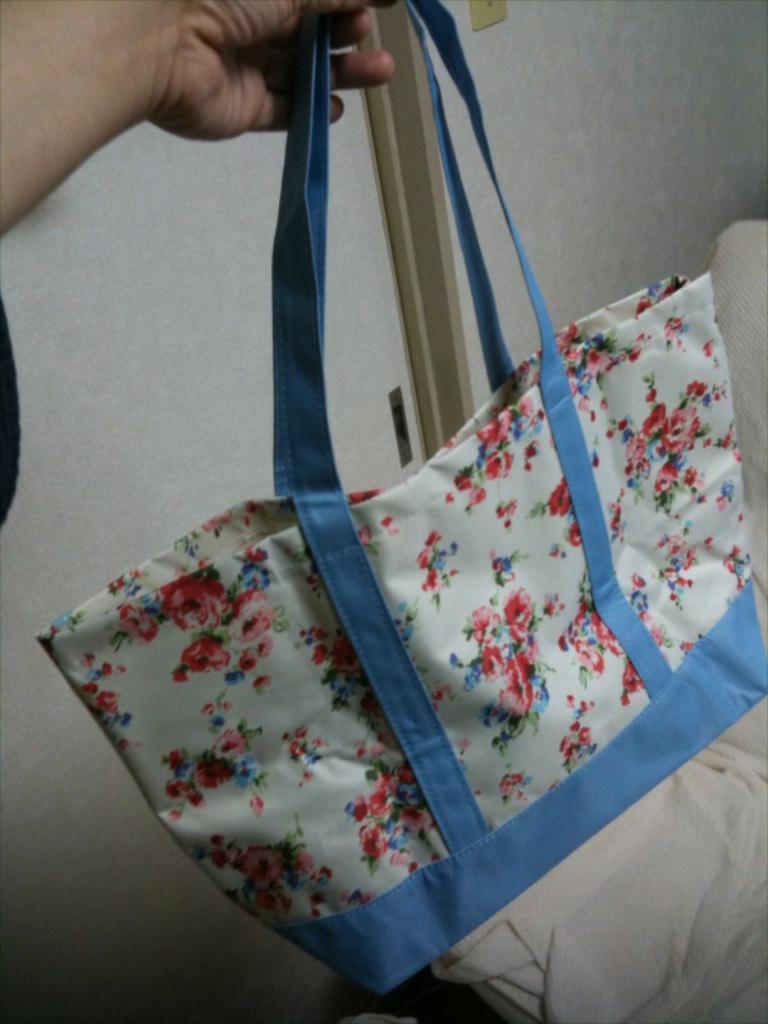Could you give a brief overview of what you see in this image? In the picture we can see person holding bag with ease and in background we can see wall, cloth. 